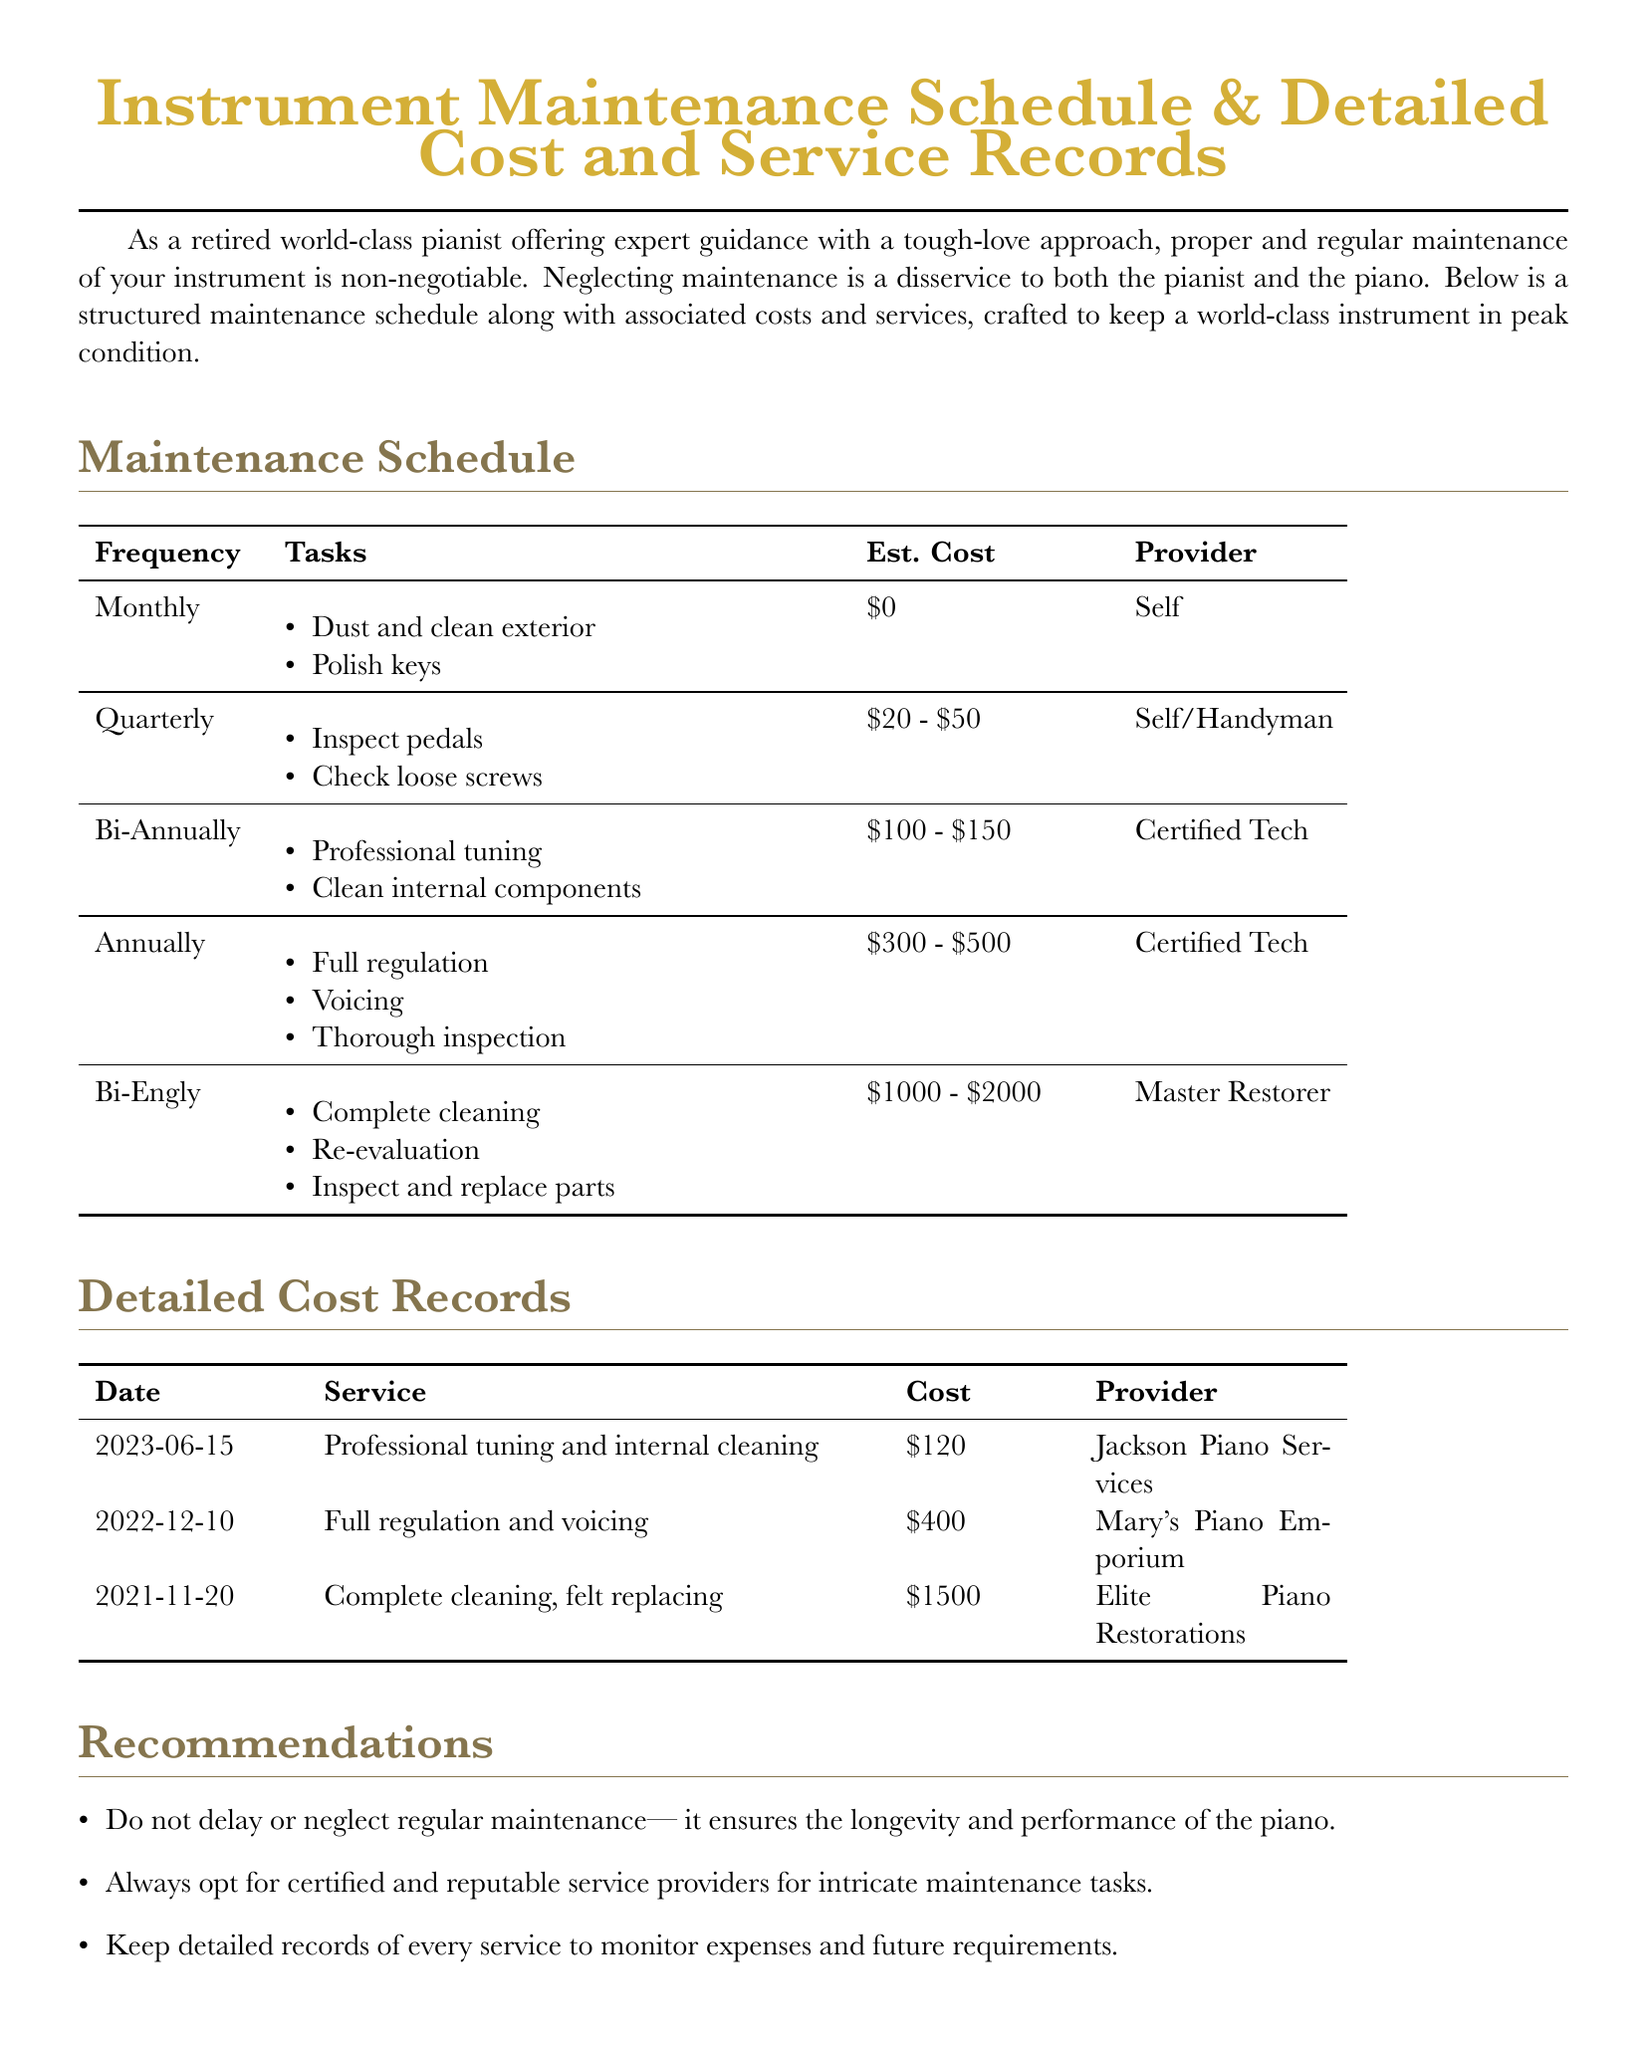What is the estimated cost for monthly maintenance? The estimated cost for monthly maintenance is listed as $0.
Answer: $0 How often should a full regulation be performed? A full regulation should be performed annually as per the schedule.
Answer: Annually Who provided the professional tuning service on June 15, 2023? The professional tuning service was provided by Jackson Piano Services.
Answer: Jackson Piano Services What is the total estimated cost range for bi-annual maintenance? The total estimated cost range for bi-annual maintenance is $1000 - $2000.
Answer: $1000 - $2000 Which service requires a Master Restorer? The complete cleaning, re-evaluation, and inspection and replacement of parts requires a Master Restorer.
Answer: Master Restorer What type of tasks are performed quarterly? Tasks performed quarterly include inspecting pedals and checking loose screws.
Answer: Inspect pedals, check loose screws What is the date of the most recent service recorded? The most recent service recorded is on June 15, 2023.
Answer: 2023-06-15 How much was charged for the full regulation and voicing? The charge for full regulation and voicing was $400.
Answer: $400 What maintenance task is done monthly? Dust and clean exterior is a maintenance task done monthly.
Answer: Dust and clean exterior 